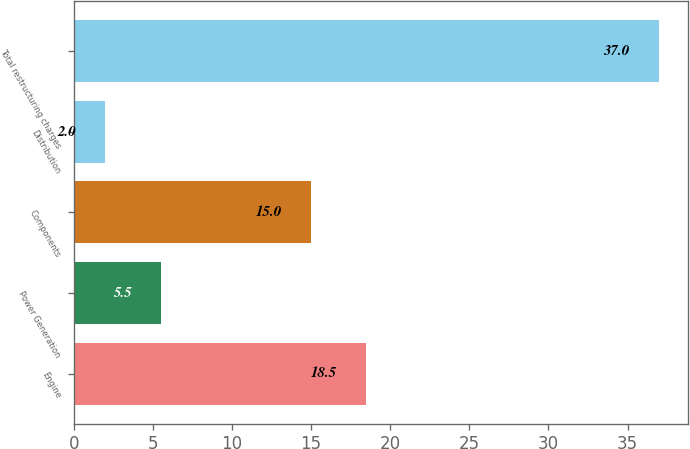<chart> <loc_0><loc_0><loc_500><loc_500><bar_chart><fcel>Engine<fcel>Power Generation<fcel>Components<fcel>Distribution<fcel>Total restructuring charges<nl><fcel>18.5<fcel>5.5<fcel>15<fcel>2<fcel>37<nl></chart> 